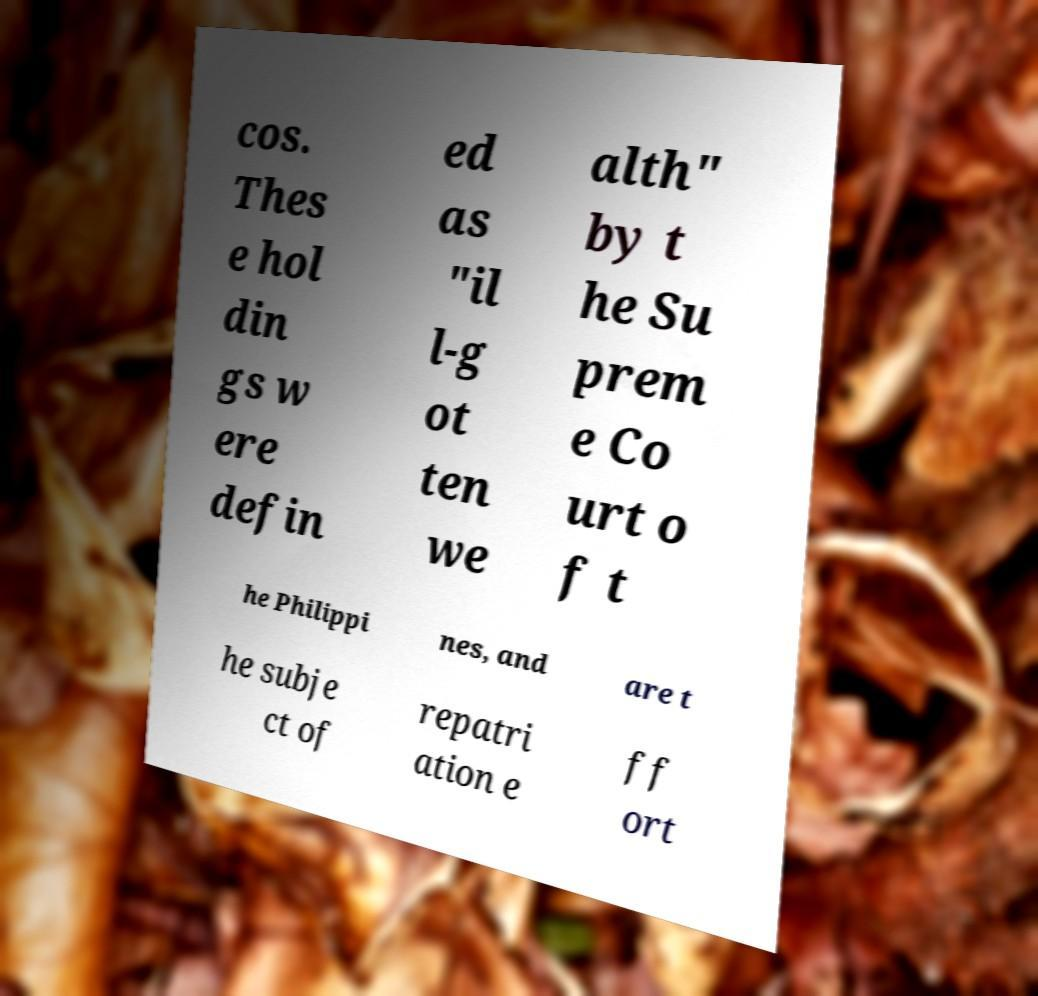Please identify and transcribe the text found in this image. cos. Thes e hol din gs w ere defin ed as "il l-g ot ten we alth" by t he Su prem e Co urt o f t he Philippi nes, and are t he subje ct of repatri ation e ff ort 